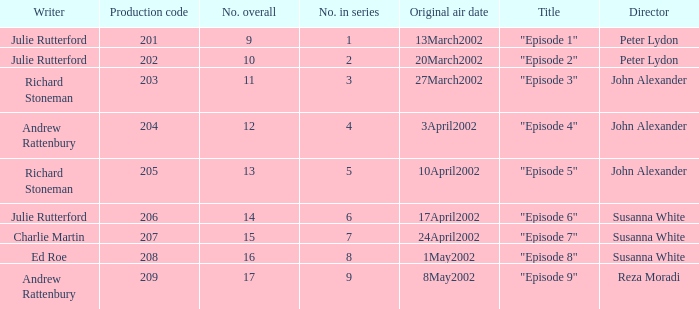When 15 is the number overall what is the original air date? 24April2002. 